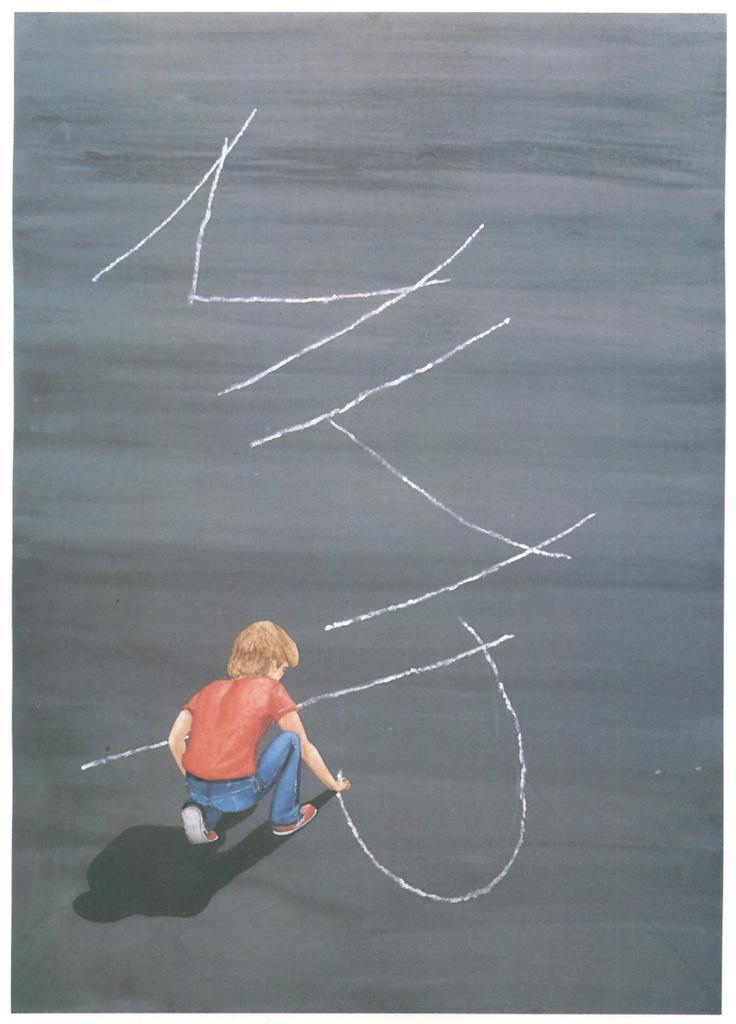In one or two sentences, can you explain what this image depicts? In this image we can see a drawing, in that, there is a person writing a text on a surface. 